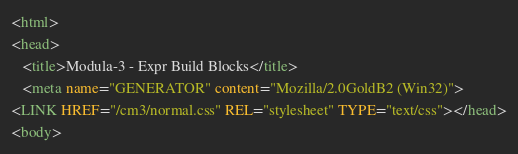Convert code to text. <code><loc_0><loc_0><loc_500><loc_500><_HTML_><html>
<head>
   <title>Modula-3 - Expr Build Blocks</title>
   <meta name="GENERATOR" content="Mozilla/2.0GoldB2 (Win32)">
<LINK HREF="/cm3/normal.css" REL="stylesheet" TYPE="text/css"></head>
<body></code> 